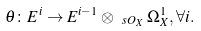<formula> <loc_0><loc_0><loc_500><loc_500>\theta \colon E ^ { i } \to E ^ { i - 1 } \otimes _ { \ s O _ { X } } \Omega ^ { 1 } _ { X } , \forall i .</formula> 